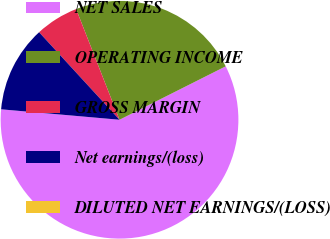Convert chart. <chart><loc_0><loc_0><loc_500><loc_500><pie_chart><fcel>NET SALES<fcel>OPERATING INCOME<fcel>GROSS MARGIN<fcel>Net earnings/(loss)<fcel>DILUTED NET EARNINGS/(LOSS)<nl><fcel>58.82%<fcel>23.53%<fcel>5.88%<fcel>11.77%<fcel>0.0%<nl></chart> 